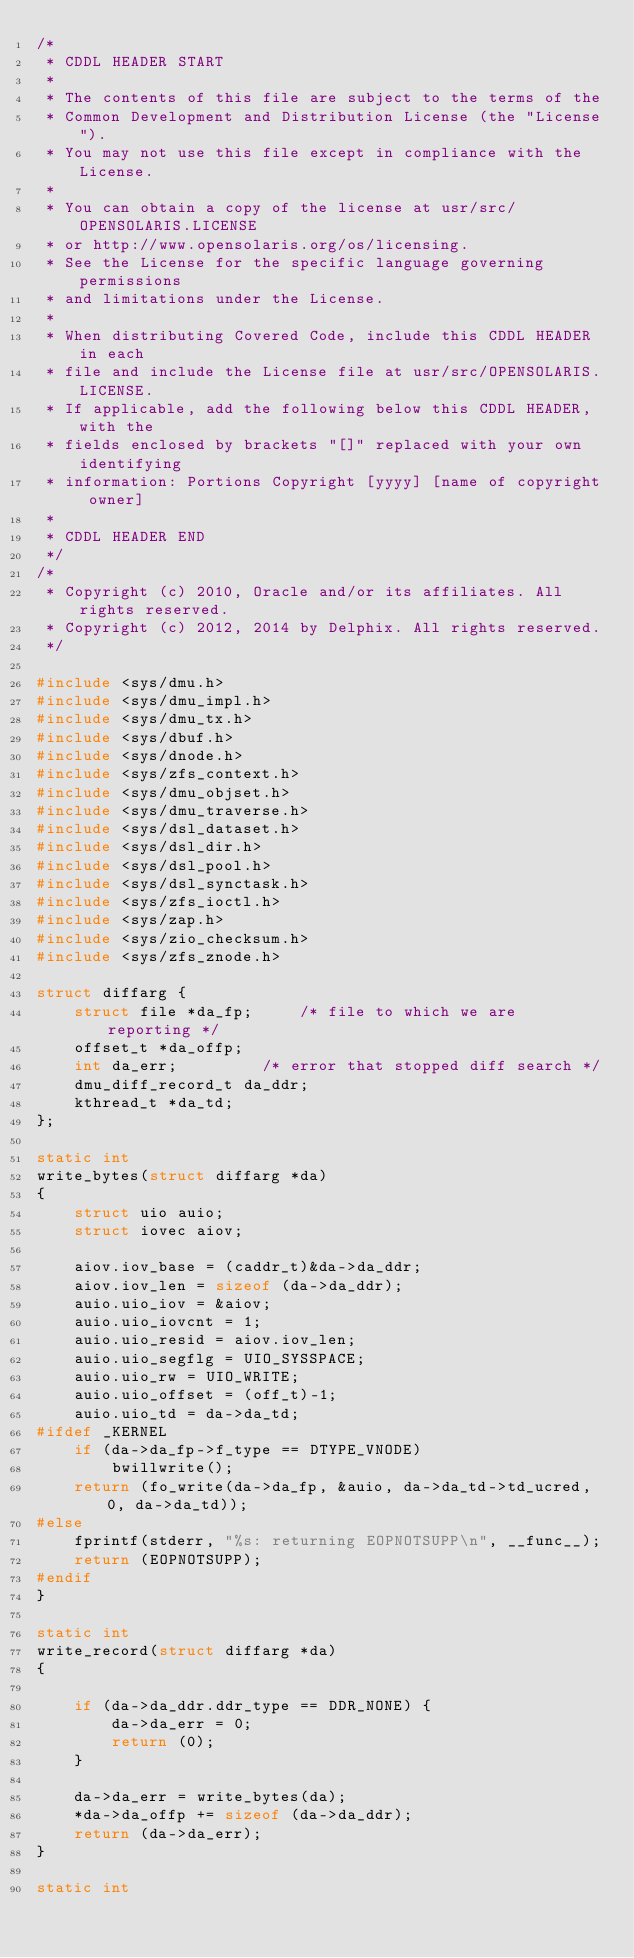<code> <loc_0><loc_0><loc_500><loc_500><_C_>/*
 * CDDL HEADER START
 *
 * The contents of this file are subject to the terms of the
 * Common Development and Distribution License (the "License").
 * You may not use this file except in compliance with the License.
 *
 * You can obtain a copy of the license at usr/src/OPENSOLARIS.LICENSE
 * or http://www.opensolaris.org/os/licensing.
 * See the License for the specific language governing permissions
 * and limitations under the License.
 *
 * When distributing Covered Code, include this CDDL HEADER in each
 * file and include the License file at usr/src/OPENSOLARIS.LICENSE.
 * If applicable, add the following below this CDDL HEADER, with the
 * fields enclosed by brackets "[]" replaced with your own identifying
 * information: Portions Copyright [yyyy] [name of copyright owner]
 *
 * CDDL HEADER END
 */
/*
 * Copyright (c) 2010, Oracle and/or its affiliates. All rights reserved.
 * Copyright (c) 2012, 2014 by Delphix. All rights reserved.
 */

#include <sys/dmu.h>
#include <sys/dmu_impl.h>
#include <sys/dmu_tx.h>
#include <sys/dbuf.h>
#include <sys/dnode.h>
#include <sys/zfs_context.h>
#include <sys/dmu_objset.h>
#include <sys/dmu_traverse.h>
#include <sys/dsl_dataset.h>
#include <sys/dsl_dir.h>
#include <sys/dsl_pool.h>
#include <sys/dsl_synctask.h>
#include <sys/zfs_ioctl.h>
#include <sys/zap.h>
#include <sys/zio_checksum.h>
#include <sys/zfs_znode.h>

struct diffarg {
	struct file *da_fp;		/* file to which we are reporting */
	offset_t *da_offp;
	int da_err;			/* error that stopped diff search */
	dmu_diff_record_t da_ddr;
	kthread_t *da_td;
};

static int
write_bytes(struct diffarg *da)
{
	struct uio auio;
	struct iovec aiov;

	aiov.iov_base = (caddr_t)&da->da_ddr;
	aiov.iov_len = sizeof (da->da_ddr);
	auio.uio_iov = &aiov;
	auio.uio_iovcnt = 1;
	auio.uio_resid = aiov.iov_len;
	auio.uio_segflg = UIO_SYSSPACE;
	auio.uio_rw = UIO_WRITE;
	auio.uio_offset = (off_t)-1;
	auio.uio_td = da->da_td;
#ifdef _KERNEL
	if (da->da_fp->f_type == DTYPE_VNODE)
		bwillwrite();
	return (fo_write(da->da_fp, &auio, da->da_td->td_ucred, 0, da->da_td));
#else
	fprintf(stderr, "%s: returning EOPNOTSUPP\n", __func__);
	return (EOPNOTSUPP);
#endif
}

static int
write_record(struct diffarg *da)
{

	if (da->da_ddr.ddr_type == DDR_NONE) {
		da->da_err = 0;
		return (0);
	}

	da->da_err = write_bytes(da);
	*da->da_offp += sizeof (da->da_ddr);
	return (da->da_err);
}

static int</code> 